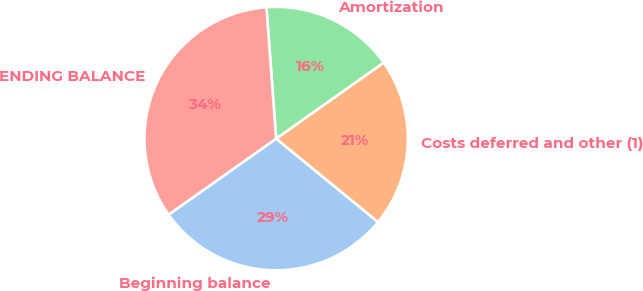<chart> <loc_0><loc_0><loc_500><loc_500><pie_chart><fcel>Beginning balance<fcel>Costs deferred and other (1)<fcel>Amortization<fcel>ENDING BALANCE<nl><fcel>29.29%<fcel>20.71%<fcel>16.38%<fcel>33.62%<nl></chart> 